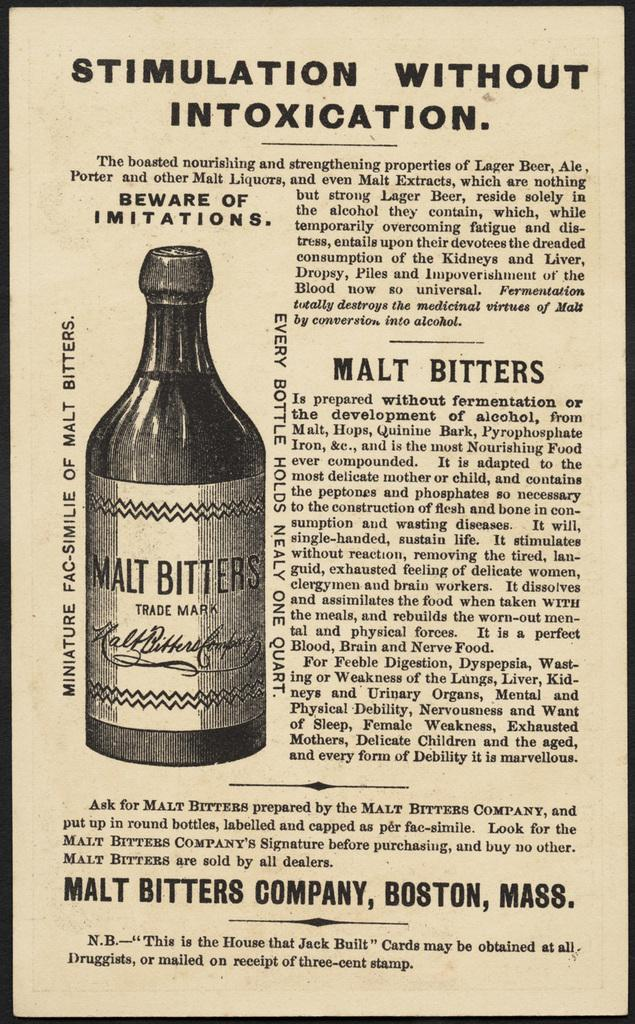<image>
Describe the image concisely. An advertisement for a bottle of Malt Bitters out of Boston, Mass.. 